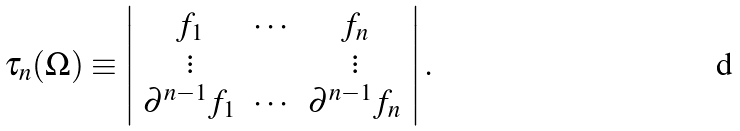<formula> <loc_0><loc_0><loc_500><loc_500>\tau _ { n } ( \Omega ) \equiv \left | \begin{array} { c c c } f _ { 1 } & \cdots & f _ { n } \\ \vdots & & \vdots \\ \partial ^ { n - 1 } f _ { 1 } & \cdots & \partial ^ { n - 1 } f _ { n } \end{array} \right | .</formula> 